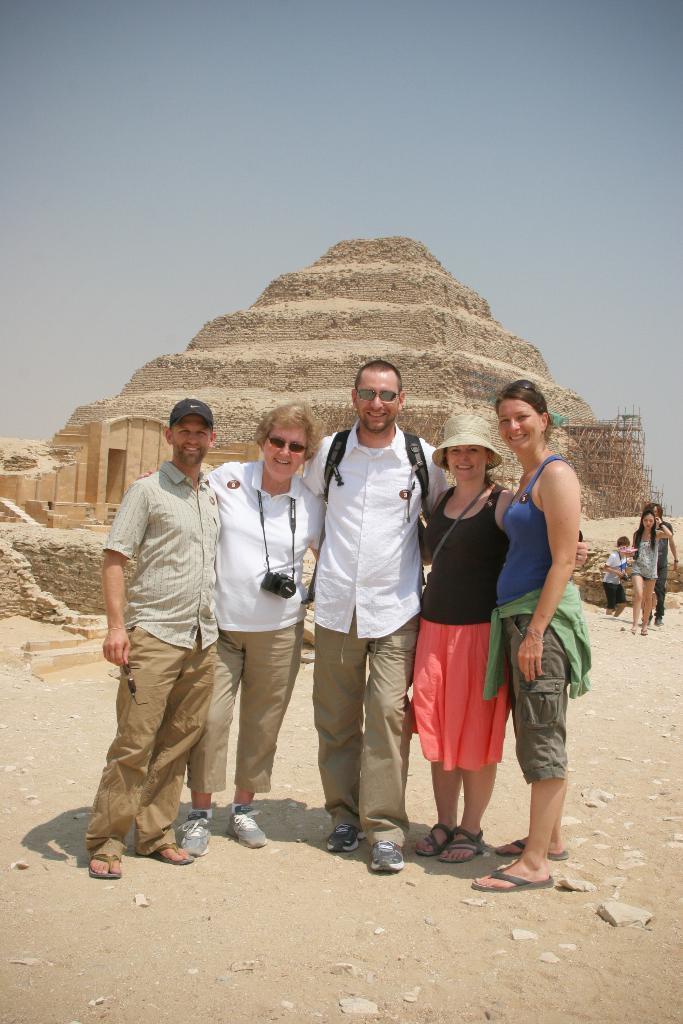Describe this image in one or two sentences. In this picture we can see the group of men and women, standing and giving a pose to the camera. Behind there is a pyramid. On the top there is a sky. 